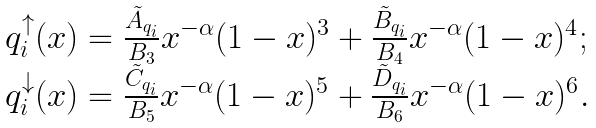<formula> <loc_0><loc_0><loc_500><loc_500>\begin{array} { c l l r } & q ^ { \uparrow } _ { i } ( x ) = \frac { \tilde { A } _ { q _ { i } } } { B _ { 3 } } x ^ { - \alpha } ( 1 - x ) ^ { 3 } + \frac { \tilde { B } _ { q _ { i } } } { B _ { 4 } } x ^ { - \alpha } ( 1 - x ) ^ { 4 } ; \\ & q ^ { \downarrow } _ { i } ( x ) = \frac { \tilde { C } _ { q _ { i } } } { B _ { 5 } } x ^ { - \alpha } ( 1 - x ) ^ { 5 } + \frac { \tilde { D } _ { q _ { i } } } { B _ { 6 } } x ^ { - \alpha } ( 1 - x ) ^ { 6 } . \end{array}</formula> 